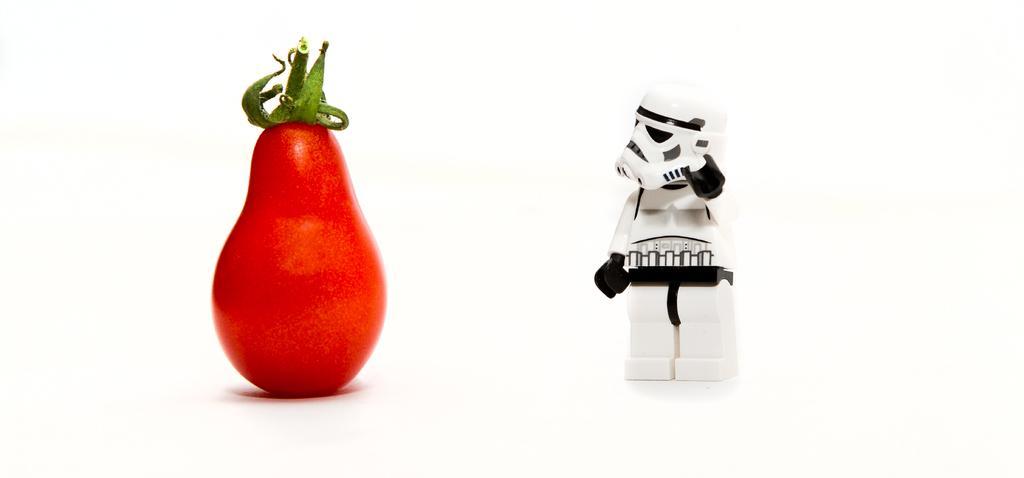Please provide a concise description of this image. In this picture we can see a vegetable and toy on a platform. 